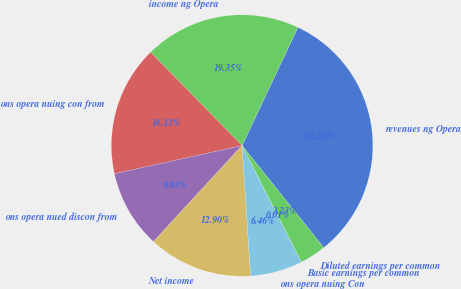Convert chart. <chart><loc_0><loc_0><loc_500><loc_500><pie_chart><fcel>revenues ng Opera<fcel>income ng Opera<fcel>ons opera nuing con from<fcel>ons opera nued discon from<fcel>Net income<fcel>ons opera nuing Con<fcel>Basic earnings per common<fcel>Diluted earnings per common<nl><fcel>32.24%<fcel>19.35%<fcel>16.13%<fcel>9.68%<fcel>12.9%<fcel>6.46%<fcel>0.01%<fcel>3.23%<nl></chart> 